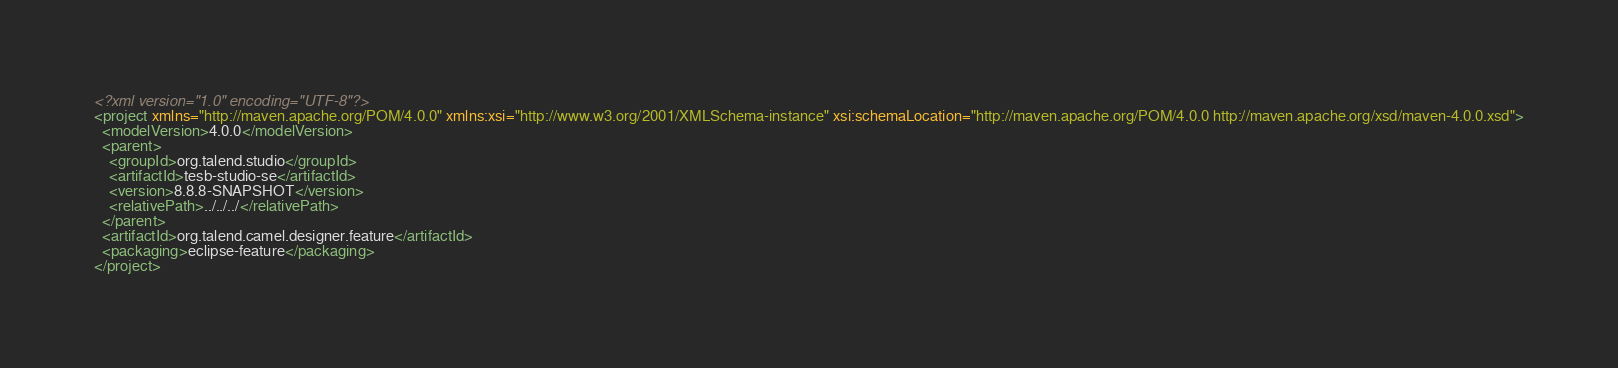<code> <loc_0><loc_0><loc_500><loc_500><_XML_><?xml version="1.0" encoding="UTF-8"?>
<project xmlns="http://maven.apache.org/POM/4.0.0" xmlns:xsi="http://www.w3.org/2001/XMLSchema-instance" xsi:schemaLocation="http://maven.apache.org/POM/4.0.0 http://maven.apache.org/xsd/maven-4.0.0.xsd">
  <modelVersion>4.0.0</modelVersion>
  <parent>
    <groupId>org.talend.studio</groupId>
    <artifactId>tesb-studio-se</artifactId>
    <version>8.8.8-SNAPSHOT</version>
    <relativePath>../../../</relativePath>
  </parent>
  <artifactId>org.talend.camel.designer.feature</artifactId>
  <packaging>eclipse-feature</packaging>
</project>
</code> 